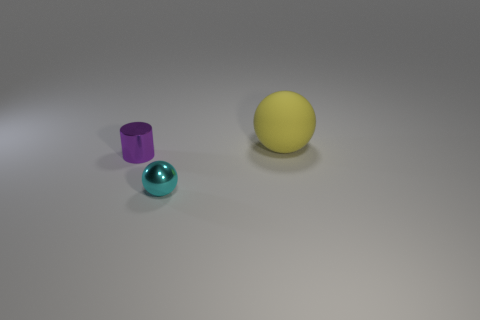Is the number of small purple shiny things to the left of the big yellow matte sphere greater than the number of blue objects?
Ensure brevity in your answer.  Yes. Are there any cubes that have the same material as the tiny ball?
Your answer should be compact. No. Is the ball that is in front of the purple thing made of the same material as the sphere that is behind the small purple cylinder?
Keep it short and to the point. No. Are there an equal number of cylinders that are to the right of the cyan metal thing and small purple cylinders in front of the small purple cylinder?
Your answer should be compact. Yes. What is the color of the shiny thing that is the same size as the cyan metal sphere?
Your answer should be very brief. Purple. Are there any shiny cylinders that have the same color as the metallic sphere?
Your answer should be very brief. No. How many things are metal things in front of the cylinder or tiny spheres?
Provide a succinct answer. 1. What number of other things are there of the same size as the shiny sphere?
Your answer should be very brief. 1. There is a ball that is in front of the sphere that is behind the ball in front of the big yellow sphere; what is it made of?
Provide a short and direct response. Metal. What number of cylinders are either large rubber things or small metallic objects?
Provide a succinct answer. 1. 